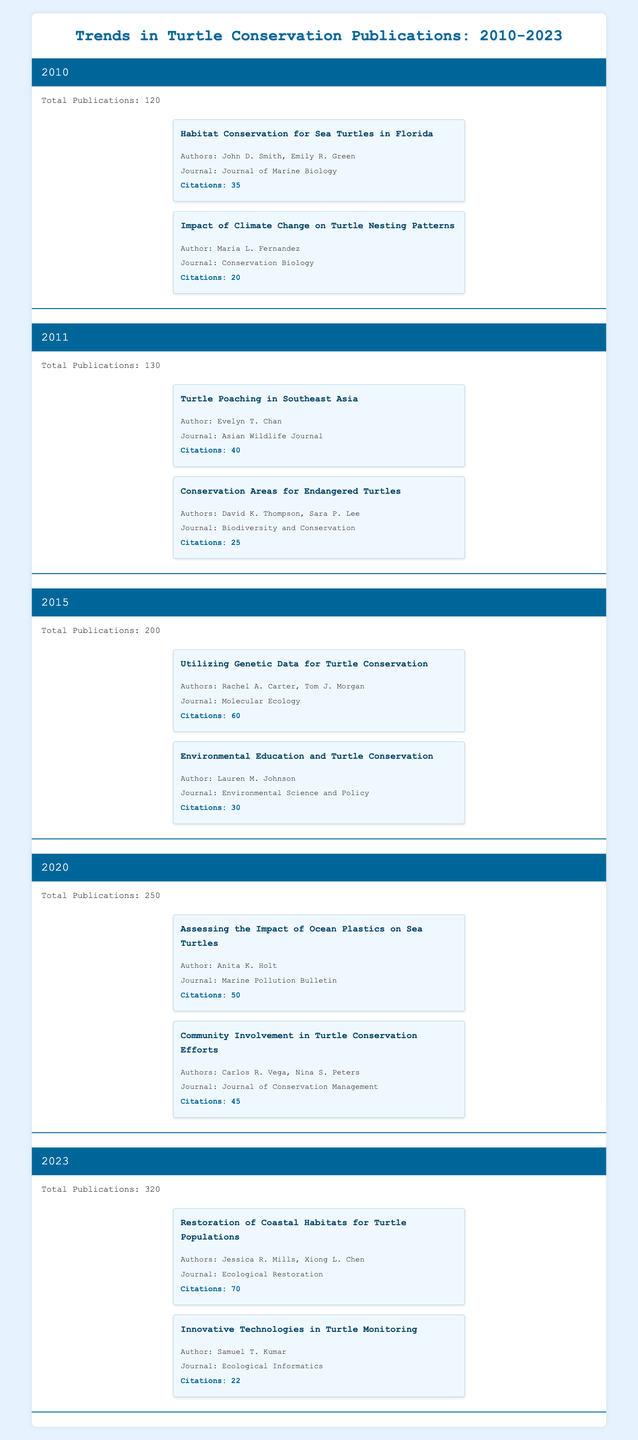What was the total number of publications in 2011? Directly refer to the table for the year 2011 where it states "Total Publications: 130"
Answer: 130 Which study from 2020 had the highest citations? In the year 2020, the studies listed are "Assessing the Impact of Ocean Plastics on Sea Turtles" with 50 citations and "Community Involvement in Turtle Conservation Efforts" with 45 citations. The former has the highest citations.
Answer: Assessing the Impact of Ocean Plastics on Sea Turtles How many total publications were there from 2010 to 2015? The total number of publications for each year is: 2010 (120), 2011 (130), 2015 (200). Since there are other years that need to be excluded, we sum the values: 120 + 130 + 200 = 450.
Answer: 450 Did the number of publications increase every year? By looking at the total publications for each year listed (120, 130, 200, 250, 320), we see that they all progressed in a rising manner, confirming that the number increased every year.
Answer: Yes What is the difference in total publications between 2023 and 2010? From the year 2023, total publications are 320 and from 2010, they are 120. The difference is calculated as 320 - 120 = 200.
Answer: 200 What is the average number of citations for key studies from 2011 to 2023? The total citations from key studies: 2011 - (40 + 25 = 65), 2015 - (60 + 30 = 90), 2020 - (50 + 45 = 95), and 2023 - (70 + 22 = 92). Summing these gives 65 + 90 + 95 + 92 = 342. There are 4 years, so dividing 342 by 4 gives 85.5.
Answer: 85.5 Which author's work had the highest citations in 2023? The studies listed in 2023 are "Restoration of Coastal Habitats for Turtle Populations" by Jessica R. Mills and Xiong L. Chen (70 citations) and "Innovative Technologies in Turtle Monitoring" by Samuel T. Kumar (22 citations). The first study had the highest citations.
Answer: Restoration of Coastal Habitats for Turtle Populations How many key studies in 2015 were authored by more than one person? In the year 2015, there are two key studies: "Utilizing Genetic Data for Turtle Conservation" (two authors) and "Environmental Education and Turtle Conservation" (one author). Since only the first has multiple authors, it counts as one.
Answer: 1 What is the total citation count for key studies from 2010 and 2011 combined? The key studies and their citations are: 2010 - (35 + 20 = 55) and 2011 - (40 + 25 = 65). Adding these gives a total of 55 + 65 = 120.
Answer: 120 